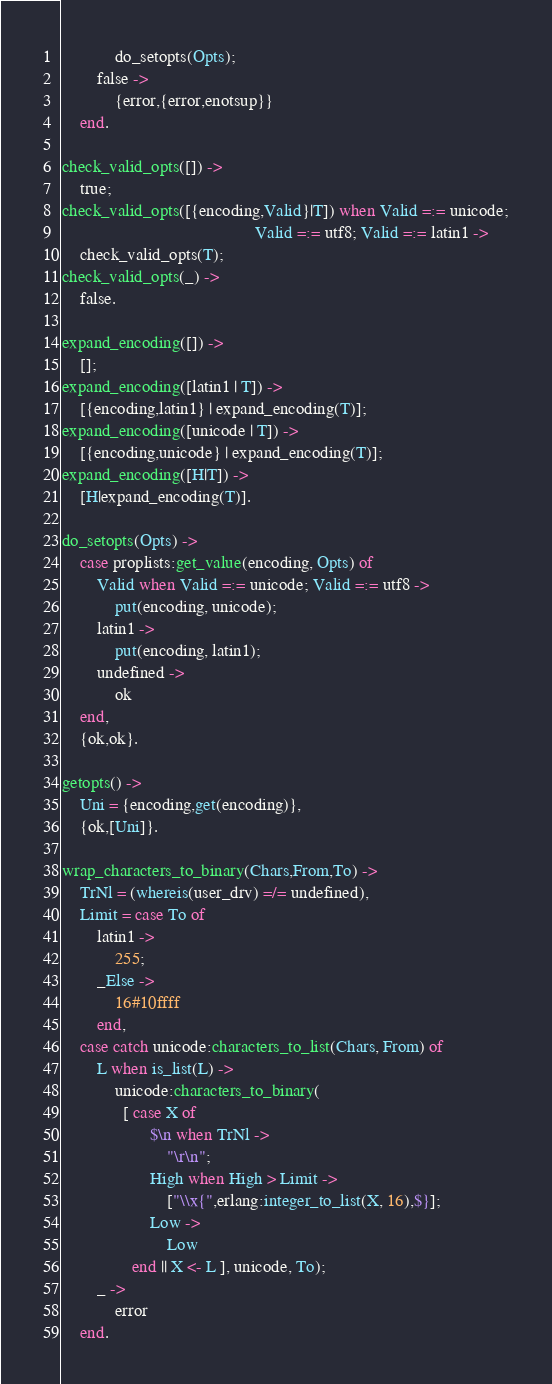Convert code to text. <code><loc_0><loc_0><loc_500><loc_500><_Erlang_>            do_setopts(Opts);
        false ->
            {error,{error,enotsup}}
    end.

check_valid_opts([]) ->
    true;
check_valid_opts([{encoding,Valid}|T]) when Valid =:= unicode;
                                            Valid =:= utf8; Valid =:= latin1 ->
    check_valid_opts(T);
check_valid_opts(_) ->
    false.

expand_encoding([]) ->
    [];
expand_encoding([latin1 | T]) ->
    [{encoding,latin1} | expand_encoding(T)];
expand_encoding([unicode | T]) ->
    [{encoding,unicode} | expand_encoding(T)];
expand_encoding([H|T]) ->
    [H|expand_encoding(T)].

do_setopts(Opts) ->
    case proplists:get_value(encoding, Opts) of
        Valid when Valid =:= unicode; Valid =:= utf8 ->
            put(encoding, unicode);
        latin1 ->
            put(encoding, latin1);
        undefined ->
            ok
    end,
    {ok,ok}.

getopts() ->
    Uni = {encoding,get(encoding)},
    {ok,[Uni]}.

wrap_characters_to_binary(Chars,From,To) ->
    TrNl = (whereis(user_drv) =/= undefined),
    Limit = case To of 
		latin1 ->
		    255;
		_Else ->
		    16#10ffff
	    end,
    case catch unicode:characters_to_list(Chars, From) of
        L when is_list(L) ->
            unicode:characters_to_binary(
              [ case X of
                    $\n when TrNl ->
                        "\r\n";
                    High when High > Limit ->
                        ["\\x{",erlang:integer_to_list(X, 16),$}];
                    Low ->
                        Low
                end || X <- L ], unicode, To);
        _ ->
            error
    end.
</code> 